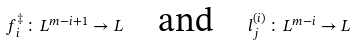Convert formula to latex. <formula><loc_0><loc_0><loc_500><loc_500>f ^ { \ddagger } _ { i } \colon L ^ { m - i + 1 } \rightarrow L \quad \text {and} \quad l ^ { ( i ) } _ { j } \colon L ^ { m - i } \rightarrow L</formula> 